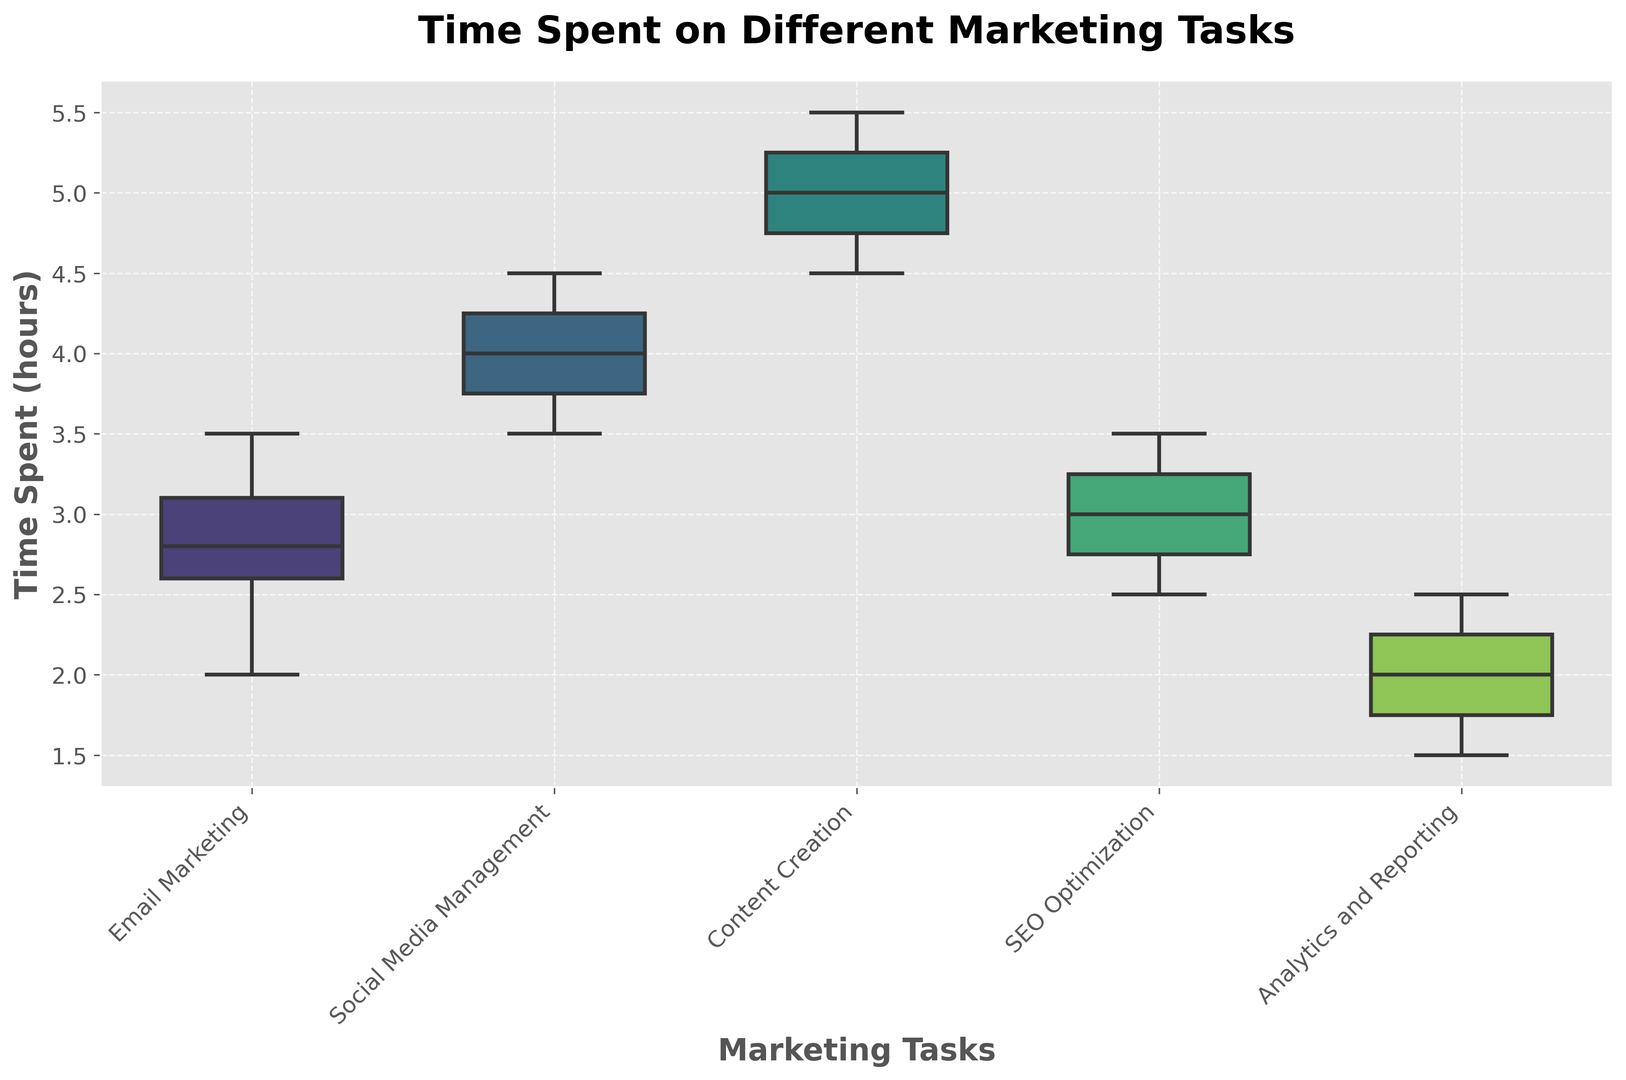What task has the highest median time spent? To find the task with the highest median time spent, look at the central line within each box which represents the median. For each task, compare these lines to see which is the highest.
Answer: Content Creation Which task has the lowest minimum time spent? To determine the task with the lowest minimum time spent, examine the lower whisker (end of the lowest vertical line) for each boxplot.
Answer: Analytics and Reporting What is the interquartile range (IQR) for SEO Optimization? The interquartile range is the distance between the lower quartile (bottom of the box) and the upper quartile (top of the box). Measure this distance for the SEO Optimization boxplot.
Answer: 0.8 Which task shows the most variability in time spent? The most variability is indicated by the largest distance between the minimum and maximum whiskers. Compare the span of the whiskers for each task.
Answer: Content Creation What is the approximate average time spent on Email Marketing tasks? To find the average, notice the concentration of data around the median and compare it with the other quartiles. The median and spread of points suggest an average around the middle of this range. Given the median and quartiles appear close, an approximate average can be derived.
Answer: Approximately 2.95 Compare the median times of Social Media Management and Content Creation. Which is higher and by how much? Determine the difference by comparing the central lines (medians) of both boxplots. Subtract the median time of Social Media Management from Content Creation.
Answer: Content Creation is higher by 1 hour Is the data for Analytics and Reporting symmetric or skewed? Symmetry in a boxplot is indicated if the median is in the center of the box and the whiskers are of equal length. Examine the box and whiskers for Analytics and Reporting.
Answer: Skewed Which task shows the smallest interquartile range (IQR)? The smallest IQR is represented by the smallest height of the box portion of the boxplot. Compare the height of the boxes across tasks.
Answer: Email Marketing How does the median time spent on Social Media Management compare to the upper quartile of SEO Optimization? Compare the central line of Social Media Management to the top of the box of SEO Optimization.
Answer: The median time for Social Media Management is higher 